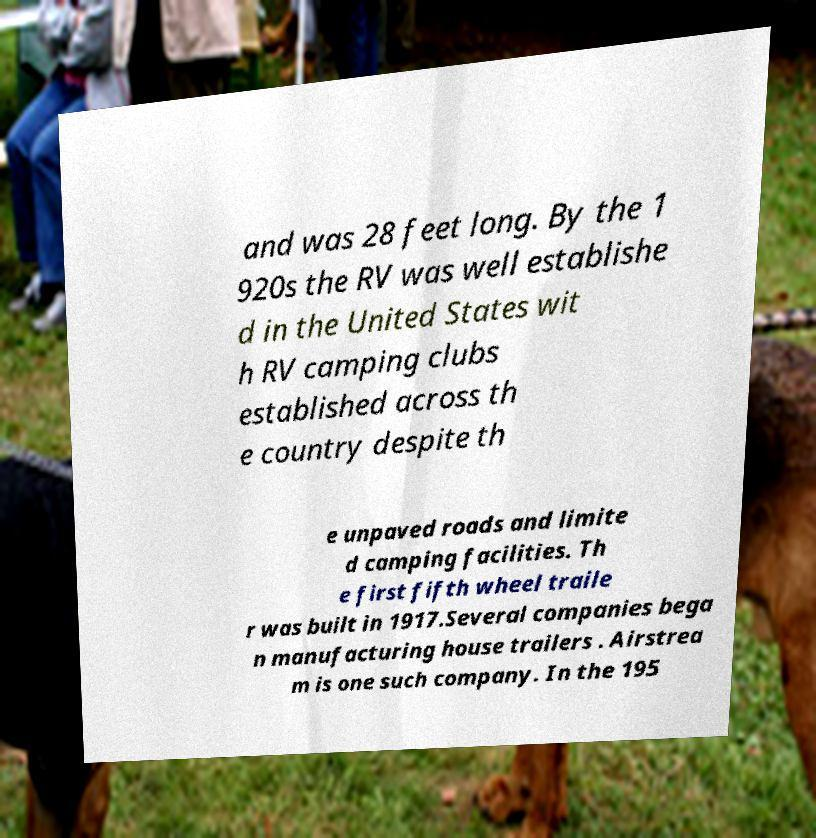Please identify and transcribe the text found in this image. and was 28 feet long. By the 1 920s the RV was well establishe d in the United States wit h RV camping clubs established across th e country despite th e unpaved roads and limite d camping facilities. Th e first fifth wheel traile r was built in 1917.Several companies bega n manufacturing house trailers . Airstrea m is one such company. In the 195 